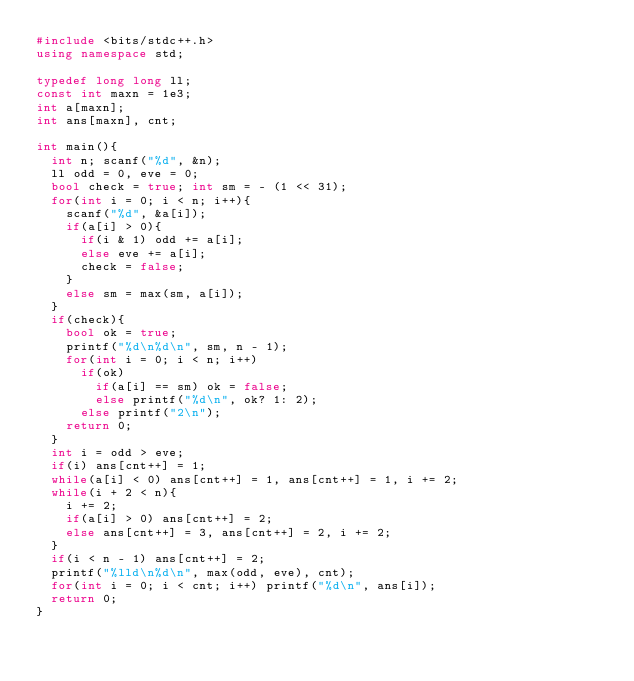<code> <loc_0><loc_0><loc_500><loc_500><_C++_>#include <bits/stdc++.h>
using namespace std;

typedef long long ll;
const int maxn = 1e3;
int a[maxn];
int ans[maxn], cnt;

int main(){
  int n; scanf("%d", &n);
  ll odd = 0, eve = 0;
  bool check = true; int sm = - (1 << 31);
  for(int i = 0; i < n; i++){
    scanf("%d", &a[i]);
    if(a[i] > 0){
      if(i & 1) odd += a[i];
      else eve += a[i];
      check = false;
    }
    else sm = max(sm, a[i]);
  }
  if(check){
    bool ok = true;
    printf("%d\n%d\n", sm, n - 1);
    for(int i = 0; i < n; i++)
      if(ok)
        if(a[i] == sm) ok = false;
        else printf("%d\n", ok? 1: 2);
      else printf("2\n");
    return 0;
  }
  int i = odd > eve;
  if(i) ans[cnt++] = 1;
  while(a[i] < 0) ans[cnt++] = 1, ans[cnt++] = 1, i += 2;
  while(i + 2 < n){
    i += 2;
    if(a[i] > 0) ans[cnt++] = 2;
    else ans[cnt++] = 3, ans[cnt++] = 2, i += 2;
  }
  if(i < n - 1) ans[cnt++] = 2;
  printf("%lld\n%d\n", max(odd, eve), cnt);
  for(int i = 0; i < cnt; i++) printf("%d\n", ans[i]);
  return 0;
}
</code> 